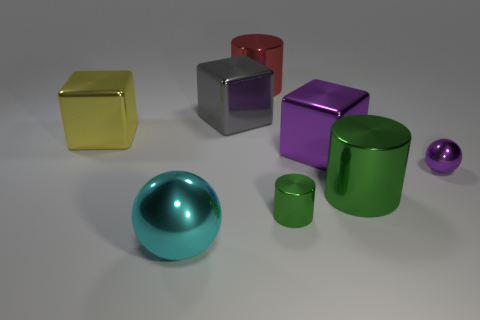There is a shiny ball that is on the left side of the sphere that is on the right side of the big cyan shiny object; what color is it?
Provide a succinct answer. Cyan. How many things are metallic spheres that are in front of the small cylinder or small shiny cylinders?
Keep it short and to the point. 2. There is a cyan sphere; does it have the same size as the yellow metallic cube in front of the gray metal object?
Your response must be concise. Yes. What number of tiny things are cyan objects or purple rubber blocks?
Your answer should be very brief. 0. What is the shape of the large green thing?
Your answer should be compact. Cylinder. There is a metal object that is the same color as the small metal sphere; what is its size?
Provide a succinct answer. Large. Is there a object that has the same material as the large sphere?
Your response must be concise. Yes. Is the number of cyan balls greater than the number of things?
Keep it short and to the point. No. Is the tiny green thing made of the same material as the yellow thing?
Offer a terse response. Yes. How many rubber things are either small purple things or tiny brown cylinders?
Keep it short and to the point. 0. 